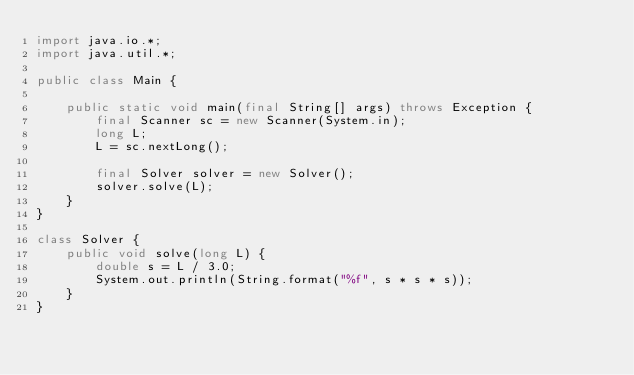<code> <loc_0><loc_0><loc_500><loc_500><_Java_>import java.io.*;
import java.util.*;

public class Main {

    public static void main(final String[] args) throws Exception {
        final Scanner sc = new Scanner(System.in);
        long L;
        L = sc.nextLong();

        final Solver solver = new Solver();
        solver.solve(L);
    }
}

class Solver {
    public void solve(long L) {
        double s = L / 3.0;
        System.out.println(String.format("%f", s * s * s));
    }
}

</code> 